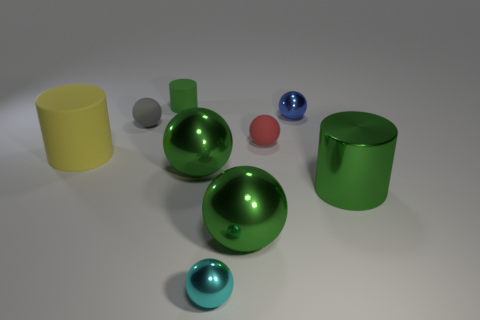What number of objects are left of the blue shiny object and in front of the blue metallic sphere?
Provide a succinct answer. 6. The metal sphere that is behind the small red object is what color?
Offer a very short reply. Blue. There is a blue object that is the same material as the big green cylinder; what size is it?
Provide a succinct answer. Small. There is a green cylinder that is behind the big metallic cylinder; what number of cyan shiny spheres are left of it?
Your answer should be compact. 0. What number of tiny red balls are behind the big yellow cylinder?
Keep it short and to the point. 1. What is the color of the big cylinder that is to the right of the small shiny ball that is left of the small metallic thing that is behind the large green cylinder?
Provide a succinct answer. Green. Do the matte cylinder that is behind the small blue thing and the rubber cylinder that is in front of the tiny red rubber object have the same color?
Provide a short and direct response. No. The big object to the left of the thing that is behind the blue ball is what shape?
Your response must be concise. Cylinder. Is there a red thing that has the same size as the yellow cylinder?
Offer a very short reply. No. How many other big matte things have the same shape as the red rubber thing?
Your answer should be compact. 0. 